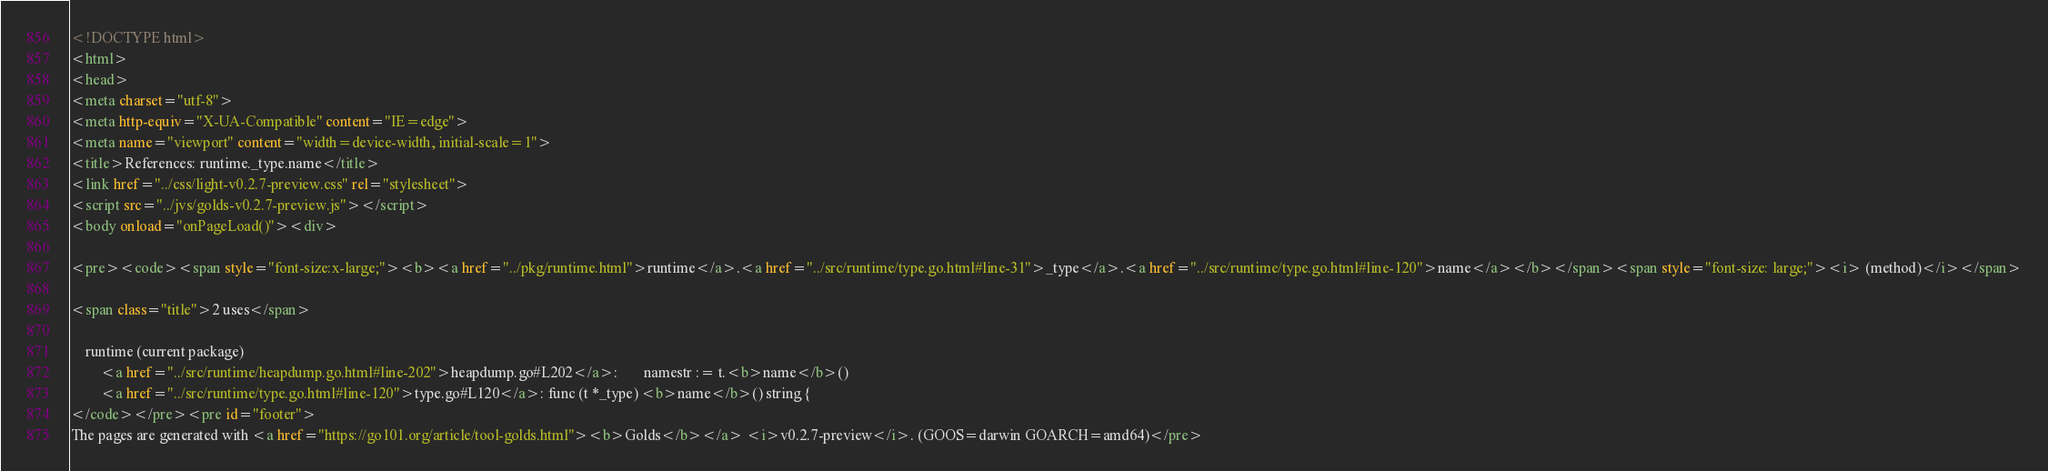Convert code to text. <code><loc_0><loc_0><loc_500><loc_500><_HTML_><!DOCTYPE html>
<html>
<head>
<meta charset="utf-8">
<meta http-equiv="X-UA-Compatible" content="IE=edge">
<meta name="viewport" content="width=device-width, initial-scale=1">
<title>References: runtime._type.name</title>
<link href="../css/light-v0.2.7-preview.css" rel="stylesheet">
<script src="../jvs/golds-v0.2.7-preview.js"></script>
<body onload="onPageLoad()"><div>

<pre><code><span style="font-size:x-large;"><b><a href="../pkg/runtime.html">runtime</a>.<a href="../src/runtime/type.go.html#line-31">_type</a>.<a href="../src/runtime/type.go.html#line-120">name</a></b></span><span style="font-size: large;"><i> (method)</i></span>

<span class="title">2 uses</span>

	runtime (current package)
		<a href="../src/runtime/heapdump.go.html#line-202">heapdump.go#L202</a>: 		namestr := t.<b>name</b>()
		<a href="../src/runtime/type.go.html#line-120">type.go#L120</a>: func (t *_type) <b>name</b>() string {
</code></pre><pre id="footer">
The pages are generated with <a href="https://go101.org/article/tool-golds.html"><b>Golds</b></a> <i>v0.2.7-preview</i>. (GOOS=darwin GOARCH=amd64)</pre></code> 